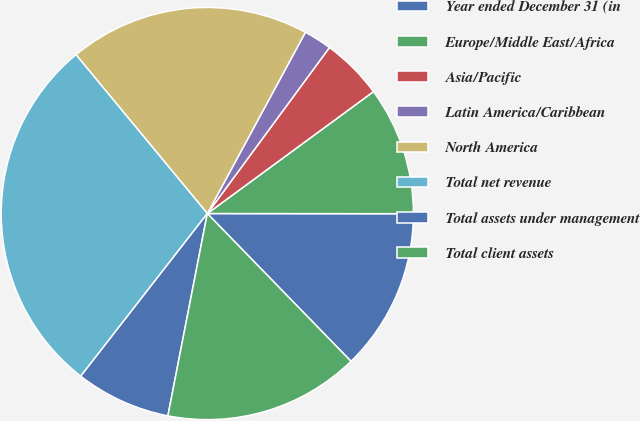Convert chart to OTSL. <chart><loc_0><loc_0><loc_500><loc_500><pie_chart><fcel>Year ended December 31 (in<fcel>Europe/Middle East/Africa<fcel>Asia/Pacific<fcel>Latin America/Caribbean<fcel>North America<fcel>Total net revenue<fcel>Total assets under management<fcel>Total client assets<nl><fcel>12.71%<fcel>10.09%<fcel>4.83%<fcel>2.2%<fcel>18.89%<fcel>28.48%<fcel>7.46%<fcel>15.34%<nl></chart> 